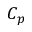Convert formula to latex. <formula><loc_0><loc_0><loc_500><loc_500>C _ { p }</formula> 